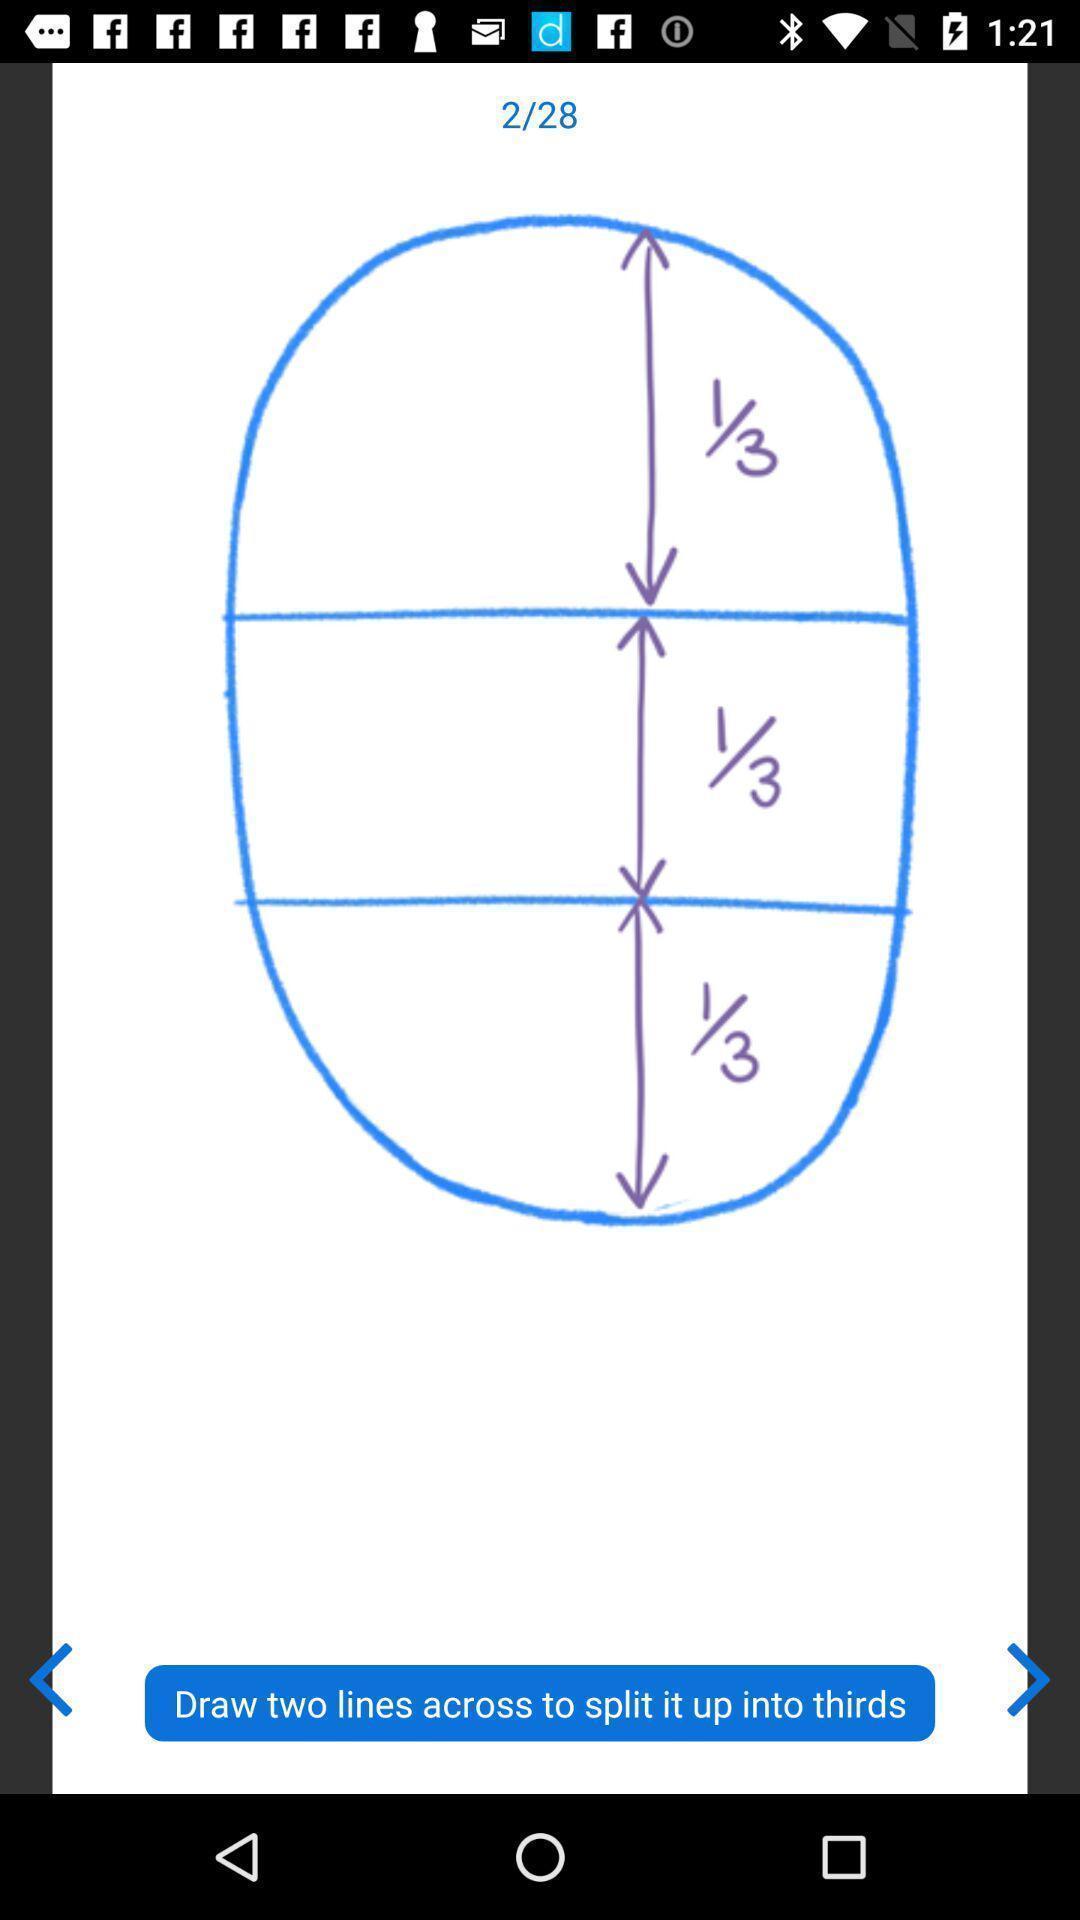Give me a narrative description of this picture. Screen showing circle divided 1/3 into three parts. 